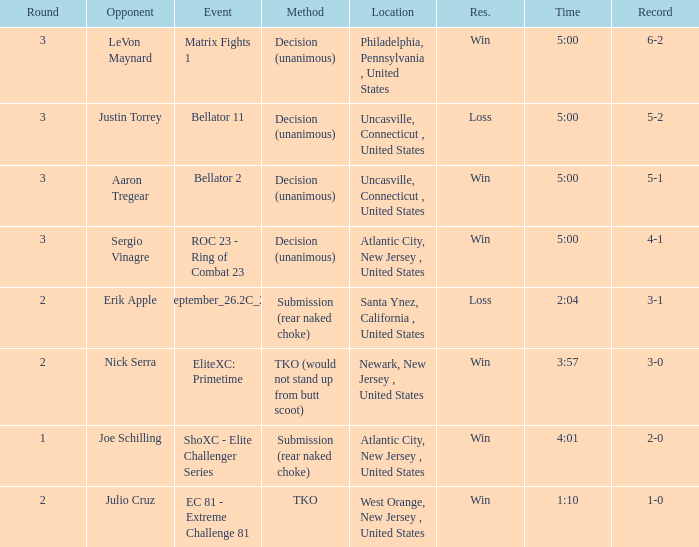Who was the opponent when there was a TKO method? Julio Cruz. 